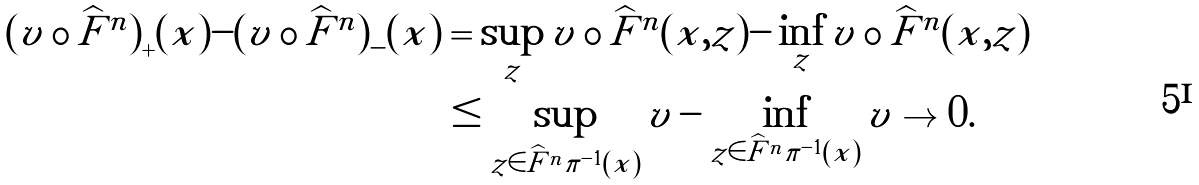Convert formula to latex. <formula><loc_0><loc_0><loc_500><loc_500>{ ( v \circ \widehat { F } ^ { n } ) } _ { + } ( x ) - { ( v \circ \widehat { F } ^ { n } ) } _ { - } ( x ) & = \sup _ { z } v \circ \widehat { F } ^ { n } ( x , z ) - \inf _ { z } v \circ \widehat { F } ^ { n } ( x , z ) \\ & \leq \sup _ { z \in \widehat { F } ^ { n } \pi ^ { - 1 } ( x ) } v - \inf _ { z \in \widehat { F } ^ { n } \pi ^ { - 1 } ( x ) } v \to 0 .</formula> 